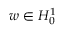<formula> <loc_0><loc_0><loc_500><loc_500>w \in H _ { 0 } ^ { 1 }</formula> 